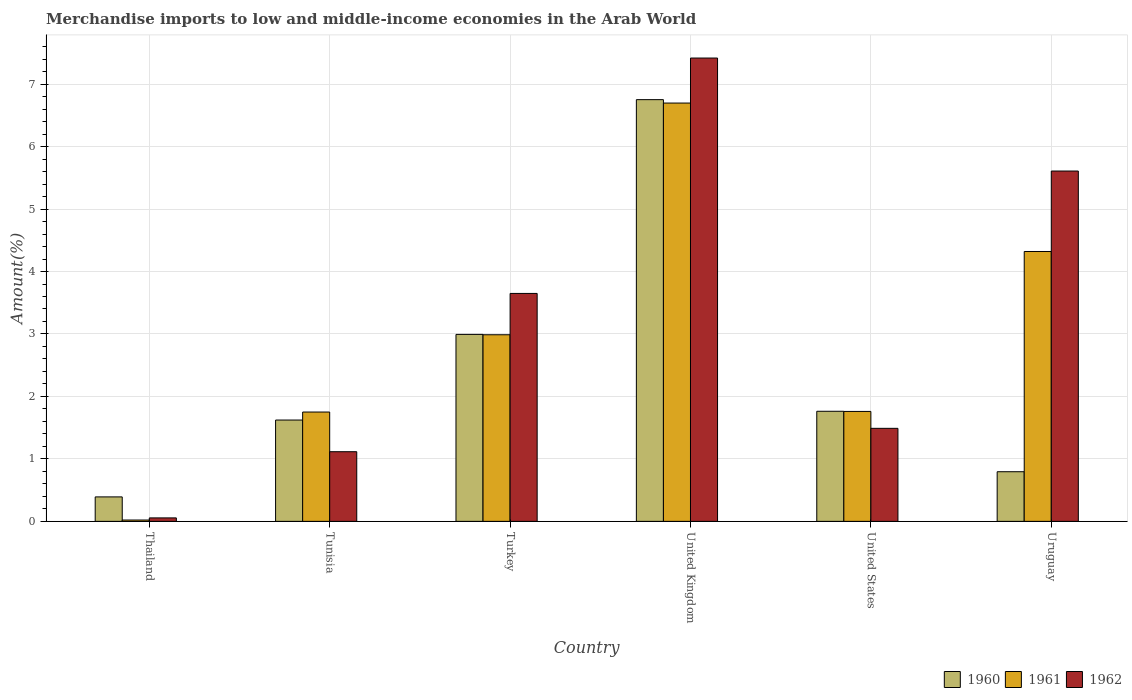How many groups of bars are there?
Ensure brevity in your answer.  6. Are the number of bars per tick equal to the number of legend labels?
Provide a succinct answer. Yes. How many bars are there on the 3rd tick from the left?
Ensure brevity in your answer.  3. How many bars are there on the 4th tick from the right?
Ensure brevity in your answer.  3. What is the label of the 4th group of bars from the left?
Offer a terse response. United Kingdom. What is the percentage of amount earned from merchandise imports in 1961 in Thailand?
Ensure brevity in your answer.  0.02. Across all countries, what is the maximum percentage of amount earned from merchandise imports in 1962?
Make the answer very short. 7.42. Across all countries, what is the minimum percentage of amount earned from merchandise imports in 1962?
Give a very brief answer. 0.06. In which country was the percentage of amount earned from merchandise imports in 1961 maximum?
Provide a short and direct response. United Kingdom. In which country was the percentage of amount earned from merchandise imports in 1961 minimum?
Your answer should be very brief. Thailand. What is the total percentage of amount earned from merchandise imports in 1961 in the graph?
Your answer should be compact. 17.54. What is the difference between the percentage of amount earned from merchandise imports in 1961 in United Kingdom and that in United States?
Your response must be concise. 4.94. What is the difference between the percentage of amount earned from merchandise imports in 1962 in Thailand and the percentage of amount earned from merchandise imports in 1961 in Tunisia?
Provide a succinct answer. -1.69. What is the average percentage of amount earned from merchandise imports in 1961 per country?
Keep it short and to the point. 2.92. What is the difference between the percentage of amount earned from merchandise imports of/in 1960 and percentage of amount earned from merchandise imports of/in 1961 in Thailand?
Keep it short and to the point. 0.37. In how many countries, is the percentage of amount earned from merchandise imports in 1960 greater than 3.6 %?
Your response must be concise. 1. What is the ratio of the percentage of amount earned from merchandise imports in 1961 in Tunisia to that in Uruguay?
Your answer should be very brief. 0.41. Is the percentage of amount earned from merchandise imports in 1962 in Tunisia less than that in United States?
Give a very brief answer. Yes. What is the difference between the highest and the second highest percentage of amount earned from merchandise imports in 1961?
Offer a terse response. -1.33. What is the difference between the highest and the lowest percentage of amount earned from merchandise imports in 1961?
Give a very brief answer. 6.68. How many bars are there?
Make the answer very short. 18. How many legend labels are there?
Make the answer very short. 3. What is the title of the graph?
Give a very brief answer. Merchandise imports to low and middle-income economies in the Arab World. Does "1966" appear as one of the legend labels in the graph?
Provide a short and direct response. No. What is the label or title of the X-axis?
Give a very brief answer. Country. What is the label or title of the Y-axis?
Make the answer very short. Amount(%). What is the Amount(%) of 1960 in Thailand?
Keep it short and to the point. 0.39. What is the Amount(%) in 1961 in Thailand?
Ensure brevity in your answer.  0.02. What is the Amount(%) of 1962 in Thailand?
Your answer should be very brief. 0.06. What is the Amount(%) of 1960 in Tunisia?
Make the answer very short. 1.62. What is the Amount(%) of 1961 in Tunisia?
Give a very brief answer. 1.75. What is the Amount(%) in 1962 in Tunisia?
Your answer should be very brief. 1.12. What is the Amount(%) of 1960 in Turkey?
Your answer should be compact. 2.99. What is the Amount(%) in 1961 in Turkey?
Offer a very short reply. 2.99. What is the Amount(%) of 1962 in Turkey?
Make the answer very short. 3.65. What is the Amount(%) of 1960 in United Kingdom?
Provide a succinct answer. 6.75. What is the Amount(%) of 1961 in United Kingdom?
Ensure brevity in your answer.  6.7. What is the Amount(%) in 1962 in United Kingdom?
Provide a succinct answer. 7.42. What is the Amount(%) of 1960 in United States?
Offer a very short reply. 1.76. What is the Amount(%) in 1961 in United States?
Your answer should be very brief. 1.76. What is the Amount(%) of 1962 in United States?
Ensure brevity in your answer.  1.49. What is the Amount(%) in 1960 in Uruguay?
Your answer should be compact. 0.79. What is the Amount(%) in 1961 in Uruguay?
Your response must be concise. 4.32. What is the Amount(%) of 1962 in Uruguay?
Your response must be concise. 5.61. Across all countries, what is the maximum Amount(%) in 1960?
Give a very brief answer. 6.75. Across all countries, what is the maximum Amount(%) in 1961?
Keep it short and to the point. 6.7. Across all countries, what is the maximum Amount(%) in 1962?
Offer a very short reply. 7.42. Across all countries, what is the minimum Amount(%) in 1960?
Keep it short and to the point. 0.39. Across all countries, what is the minimum Amount(%) in 1961?
Provide a short and direct response. 0.02. Across all countries, what is the minimum Amount(%) of 1962?
Your answer should be compact. 0.06. What is the total Amount(%) in 1960 in the graph?
Keep it short and to the point. 14.32. What is the total Amount(%) in 1961 in the graph?
Your answer should be very brief. 17.54. What is the total Amount(%) of 1962 in the graph?
Ensure brevity in your answer.  19.34. What is the difference between the Amount(%) of 1960 in Thailand and that in Tunisia?
Keep it short and to the point. -1.23. What is the difference between the Amount(%) in 1961 in Thailand and that in Tunisia?
Your answer should be very brief. -1.73. What is the difference between the Amount(%) of 1962 in Thailand and that in Tunisia?
Your answer should be compact. -1.06. What is the difference between the Amount(%) in 1960 in Thailand and that in Turkey?
Provide a succinct answer. -2.6. What is the difference between the Amount(%) of 1961 in Thailand and that in Turkey?
Provide a short and direct response. -2.97. What is the difference between the Amount(%) of 1962 in Thailand and that in Turkey?
Provide a succinct answer. -3.59. What is the difference between the Amount(%) of 1960 in Thailand and that in United Kingdom?
Provide a succinct answer. -6.36. What is the difference between the Amount(%) in 1961 in Thailand and that in United Kingdom?
Keep it short and to the point. -6.68. What is the difference between the Amount(%) of 1962 in Thailand and that in United Kingdom?
Make the answer very short. -7.36. What is the difference between the Amount(%) of 1960 in Thailand and that in United States?
Your answer should be compact. -1.37. What is the difference between the Amount(%) of 1961 in Thailand and that in United States?
Make the answer very short. -1.74. What is the difference between the Amount(%) in 1962 in Thailand and that in United States?
Ensure brevity in your answer.  -1.43. What is the difference between the Amount(%) of 1960 in Thailand and that in Uruguay?
Offer a very short reply. -0.4. What is the difference between the Amount(%) in 1961 in Thailand and that in Uruguay?
Give a very brief answer. -4.3. What is the difference between the Amount(%) of 1962 in Thailand and that in Uruguay?
Offer a terse response. -5.55. What is the difference between the Amount(%) of 1960 in Tunisia and that in Turkey?
Provide a succinct answer. -1.37. What is the difference between the Amount(%) of 1961 in Tunisia and that in Turkey?
Keep it short and to the point. -1.24. What is the difference between the Amount(%) in 1962 in Tunisia and that in Turkey?
Provide a short and direct response. -2.53. What is the difference between the Amount(%) in 1960 in Tunisia and that in United Kingdom?
Make the answer very short. -5.13. What is the difference between the Amount(%) in 1961 in Tunisia and that in United Kingdom?
Offer a terse response. -4.95. What is the difference between the Amount(%) of 1962 in Tunisia and that in United Kingdom?
Ensure brevity in your answer.  -6.3. What is the difference between the Amount(%) in 1960 in Tunisia and that in United States?
Offer a terse response. -0.14. What is the difference between the Amount(%) in 1961 in Tunisia and that in United States?
Offer a very short reply. -0.01. What is the difference between the Amount(%) of 1962 in Tunisia and that in United States?
Your response must be concise. -0.37. What is the difference between the Amount(%) of 1960 in Tunisia and that in Uruguay?
Give a very brief answer. 0.83. What is the difference between the Amount(%) of 1961 in Tunisia and that in Uruguay?
Give a very brief answer. -2.57. What is the difference between the Amount(%) of 1962 in Tunisia and that in Uruguay?
Your answer should be compact. -4.49. What is the difference between the Amount(%) in 1960 in Turkey and that in United Kingdom?
Give a very brief answer. -3.76. What is the difference between the Amount(%) in 1961 in Turkey and that in United Kingdom?
Your response must be concise. -3.71. What is the difference between the Amount(%) of 1962 in Turkey and that in United Kingdom?
Make the answer very short. -3.77. What is the difference between the Amount(%) in 1960 in Turkey and that in United States?
Offer a very short reply. 1.23. What is the difference between the Amount(%) of 1961 in Turkey and that in United States?
Your answer should be very brief. 1.23. What is the difference between the Amount(%) of 1962 in Turkey and that in United States?
Keep it short and to the point. 2.16. What is the difference between the Amount(%) in 1960 in Turkey and that in Uruguay?
Provide a short and direct response. 2.2. What is the difference between the Amount(%) in 1961 in Turkey and that in Uruguay?
Provide a short and direct response. -1.33. What is the difference between the Amount(%) in 1962 in Turkey and that in Uruguay?
Provide a short and direct response. -1.96. What is the difference between the Amount(%) in 1960 in United Kingdom and that in United States?
Your answer should be very brief. 4.99. What is the difference between the Amount(%) in 1961 in United Kingdom and that in United States?
Give a very brief answer. 4.94. What is the difference between the Amount(%) in 1962 in United Kingdom and that in United States?
Your answer should be compact. 5.93. What is the difference between the Amount(%) in 1960 in United Kingdom and that in Uruguay?
Your response must be concise. 5.96. What is the difference between the Amount(%) in 1961 in United Kingdom and that in Uruguay?
Your answer should be compact. 2.38. What is the difference between the Amount(%) of 1962 in United Kingdom and that in Uruguay?
Your answer should be compact. 1.81. What is the difference between the Amount(%) of 1960 in United States and that in Uruguay?
Your response must be concise. 0.97. What is the difference between the Amount(%) of 1961 in United States and that in Uruguay?
Provide a short and direct response. -2.56. What is the difference between the Amount(%) of 1962 in United States and that in Uruguay?
Offer a very short reply. -4.12. What is the difference between the Amount(%) in 1960 in Thailand and the Amount(%) in 1961 in Tunisia?
Keep it short and to the point. -1.36. What is the difference between the Amount(%) in 1960 in Thailand and the Amount(%) in 1962 in Tunisia?
Make the answer very short. -0.72. What is the difference between the Amount(%) in 1961 in Thailand and the Amount(%) in 1962 in Tunisia?
Offer a very short reply. -1.09. What is the difference between the Amount(%) of 1960 in Thailand and the Amount(%) of 1961 in Turkey?
Offer a terse response. -2.6. What is the difference between the Amount(%) of 1960 in Thailand and the Amount(%) of 1962 in Turkey?
Your answer should be compact. -3.26. What is the difference between the Amount(%) in 1961 in Thailand and the Amount(%) in 1962 in Turkey?
Ensure brevity in your answer.  -3.63. What is the difference between the Amount(%) of 1960 in Thailand and the Amount(%) of 1961 in United Kingdom?
Provide a succinct answer. -6.31. What is the difference between the Amount(%) in 1960 in Thailand and the Amount(%) in 1962 in United Kingdom?
Provide a short and direct response. -7.03. What is the difference between the Amount(%) in 1961 in Thailand and the Amount(%) in 1962 in United Kingdom?
Offer a very short reply. -7.4. What is the difference between the Amount(%) in 1960 in Thailand and the Amount(%) in 1961 in United States?
Offer a very short reply. -1.37. What is the difference between the Amount(%) in 1960 in Thailand and the Amount(%) in 1962 in United States?
Provide a short and direct response. -1.1. What is the difference between the Amount(%) of 1961 in Thailand and the Amount(%) of 1962 in United States?
Make the answer very short. -1.47. What is the difference between the Amount(%) of 1960 in Thailand and the Amount(%) of 1961 in Uruguay?
Provide a succinct answer. -3.93. What is the difference between the Amount(%) in 1960 in Thailand and the Amount(%) in 1962 in Uruguay?
Make the answer very short. -5.22. What is the difference between the Amount(%) in 1961 in Thailand and the Amount(%) in 1962 in Uruguay?
Ensure brevity in your answer.  -5.59. What is the difference between the Amount(%) of 1960 in Tunisia and the Amount(%) of 1961 in Turkey?
Keep it short and to the point. -1.37. What is the difference between the Amount(%) of 1960 in Tunisia and the Amount(%) of 1962 in Turkey?
Provide a short and direct response. -2.03. What is the difference between the Amount(%) in 1961 in Tunisia and the Amount(%) in 1962 in Turkey?
Offer a terse response. -1.9. What is the difference between the Amount(%) in 1960 in Tunisia and the Amount(%) in 1961 in United Kingdom?
Your response must be concise. -5.07. What is the difference between the Amount(%) of 1960 in Tunisia and the Amount(%) of 1962 in United Kingdom?
Your answer should be compact. -5.8. What is the difference between the Amount(%) of 1961 in Tunisia and the Amount(%) of 1962 in United Kingdom?
Your answer should be compact. -5.67. What is the difference between the Amount(%) of 1960 in Tunisia and the Amount(%) of 1961 in United States?
Ensure brevity in your answer.  -0.14. What is the difference between the Amount(%) of 1960 in Tunisia and the Amount(%) of 1962 in United States?
Offer a terse response. 0.13. What is the difference between the Amount(%) of 1961 in Tunisia and the Amount(%) of 1962 in United States?
Give a very brief answer. 0.26. What is the difference between the Amount(%) of 1960 in Tunisia and the Amount(%) of 1961 in Uruguay?
Your answer should be very brief. -2.7. What is the difference between the Amount(%) in 1960 in Tunisia and the Amount(%) in 1962 in Uruguay?
Your answer should be very brief. -3.99. What is the difference between the Amount(%) of 1961 in Tunisia and the Amount(%) of 1962 in Uruguay?
Provide a short and direct response. -3.86. What is the difference between the Amount(%) in 1960 in Turkey and the Amount(%) in 1961 in United Kingdom?
Give a very brief answer. -3.7. What is the difference between the Amount(%) in 1960 in Turkey and the Amount(%) in 1962 in United Kingdom?
Your answer should be very brief. -4.42. What is the difference between the Amount(%) in 1961 in Turkey and the Amount(%) in 1962 in United Kingdom?
Your answer should be compact. -4.43. What is the difference between the Amount(%) in 1960 in Turkey and the Amount(%) in 1961 in United States?
Your response must be concise. 1.23. What is the difference between the Amount(%) of 1960 in Turkey and the Amount(%) of 1962 in United States?
Provide a succinct answer. 1.5. What is the difference between the Amount(%) of 1961 in Turkey and the Amount(%) of 1962 in United States?
Give a very brief answer. 1.5. What is the difference between the Amount(%) of 1960 in Turkey and the Amount(%) of 1961 in Uruguay?
Offer a very short reply. -1.33. What is the difference between the Amount(%) of 1960 in Turkey and the Amount(%) of 1962 in Uruguay?
Ensure brevity in your answer.  -2.62. What is the difference between the Amount(%) of 1961 in Turkey and the Amount(%) of 1962 in Uruguay?
Offer a terse response. -2.62. What is the difference between the Amount(%) in 1960 in United Kingdom and the Amount(%) in 1961 in United States?
Provide a short and direct response. 4.99. What is the difference between the Amount(%) in 1960 in United Kingdom and the Amount(%) in 1962 in United States?
Provide a short and direct response. 5.26. What is the difference between the Amount(%) of 1961 in United Kingdom and the Amount(%) of 1962 in United States?
Provide a succinct answer. 5.21. What is the difference between the Amount(%) in 1960 in United Kingdom and the Amount(%) in 1961 in Uruguay?
Ensure brevity in your answer.  2.43. What is the difference between the Amount(%) in 1960 in United Kingdom and the Amount(%) in 1962 in Uruguay?
Your response must be concise. 1.14. What is the difference between the Amount(%) in 1961 in United Kingdom and the Amount(%) in 1962 in Uruguay?
Your answer should be very brief. 1.09. What is the difference between the Amount(%) of 1960 in United States and the Amount(%) of 1961 in Uruguay?
Make the answer very short. -2.56. What is the difference between the Amount(%) of 1960 in United States and the Amount(%) of 1962 in Uruguay?
Your answer should be very brief. -3.85. What is the difference between the Amount(%) in 1961 in United States and the Amount(%) in 1962 in Uruguay?
Offer a terse response. -3.85. What is the average Amount(%) in 1960 per country?
Offer a very short reply. 2.39. What is the average Amount(%) in 1961 per country?
Your response must be concise. 2.92. What is the average Amount(%) in 1962 per country?
Offer a very short reply. 3.22. What is the difference between the Amount(%) of 1960 and Amount(%) of 1961 in Thailand?
Your response must be concise. 0.37. What is the difference between the Amount(%) in 1960 and Amount(%) in 1962 in Thailand?
Your answer should be compact. 0.34. What is the difference between the Amount(%) of 1961 and Amount(%) of 1962 in Thailand?
Provide a short and direct response. -0.03. What is the difference between the Amount(%) of 1960 and Amount(%) of 1961 in Tunisia?
Your answer should be very brief. -0.13. What is the difference between the Amount(%) in 1960 and Amount(%) in 1962 in Tunisia?
Give a very brief answer. 0.51. What is the difference between the Amount(%) of 1961 and Amount(%) of 1962 in Tunisia?
Offer a very short reply. 0.64. What is the difference between the Amount(%) of 1960 and Amount(%) of 1961 in Turkey?
Your response must be concise. 0.01. What is the difference between the Amount(%) of 1960 and Amount(%) of 1962 in Turkey?
Offer a very short reply. -0.66. What is the difference between the Amount(%) of 1961 and Amount(%) of 1962 in Turkey?
Provide a short and direct response. -0.66. What is the difference between the Amount(%) in 1960 and Amount(%) in 1961 in United Kingdom?
Your response must be concise. 0.05. What is the difference between the Amount(%) in 1960 and Amount(%) in 1962 in United Kingdom?
Offer a terse response. -0.67. What is the difference between the Amount(%) of 1961 and Amount(%) of 1962 in United Kingdom?
Keep it short and to the point. -0.72. What is the difference between the Amount(%) in 1960 and Amount(%) in 1961 in United States?
Provide a short and direct response. 0. What is the difference between the Amount(%) of 1960 and Amount(%) of 1962 in United States?
Provide a succinct answer. 0.27. What is the difference between the Amount(%) of 1961 and Amount(%) of 1962 in United States?
Ensure brevity in your answer.  0.27. What is the difference between the Amount(%) in 1960 and Amount(%) in 1961 in Uruguay?
Your answer should be compact. -3.53. What is the difference between the Amount(%) in 1960 and Amount(%) in 1962 in Uruguay?
Offer a very short reply. -4.81. What is the difference between the Amount(%) of 1961 and Amount(%) of 1962 in Uruguay?
Give a very brief answer. -1.29. What is the ratio of the Amount(%) in 1960 in Thailand to that in Tunisia?
Offer a terse response. 0.24. What is the ratio of the Amount(%) in 1961 in Thailand to that in Tunisia?
Your answer should be very brief. 0.01. What is the ratio of the Amount(%) in 1962 in Thailand to that in Tunisia?
Keep it short and to the point. 0.05. What is the ratio of the Amount(%) in 1960 in Thailand to that in Turkey?
Keep it short and to the point. 0.13. What is the ratio of the Amount(%) in 1961 in Thailand to that in Turkey?
Provide a succinct answer. 0.01. What is the ratio of the Amount(%) in 1962 in Thailand to that in Turkey?
Offer a terse response. 0.02. What is the ratio of the Amount(%) in 1960 in Thailand to that in United Kingdom?
Your answer should be compact. 0.06. What is the ratio of the Amount(%) in 1961 in Thailand to that in United Kingdom?
Your answer should be compact. 0. What is the ratio of the Amount(%) in 1962 in Thailand to that in United Kingdom?
Your answer should be very brief. 0.01. What is the ratio of the Amount(%) of 1960 in Thailand to that in United States?
Give a very brief answer. 0.22. What is the ratio of the Amount(%) in 1961 in Thailand to that in United States?
Offer a very short reply. 0.01. What is the ratio of the Amount(%) of 1962 in Thailand to that in United States?
Offer a terse response. 0.04. What is the ratio of the Amount(%) of 1960 in Thailand to that in Uruguay?
Ensure brevity in your answer.  0.49. What is the ratio of the Amount(%) in 1961 in Thailand to that in Uruguay?
Your answer should be very brief. 0. What is the ratio of the Amount(%) in 1962 in Thailand to that in Uruguay?
Your response must be concise. 0.01. What is the ratio of the Amount(%) of 1960 in Tunisia to that in Turkey?
Provide a succinct answer. 0.54. What is the ratio of the Amount(%) in 1961 in Tunisia to that in Turkey?
Your response must be concise. 0.59. What is the ratio of the Amount(%) in 1962 in Tunisia to that in Turkey?
Provide a short and direct response. 0.31. What is the ratio of the Amount(%) of 1960 in Tunisia to that in United Kingdom?
Provide a succinct answer. 0.24. What is the ratio of the Amount(%) of 1961 in Tunisia to that in United Kingdom?
Ensure brevity in your answer.  0.26. What is the ratio of the Amount(%) in 1962 in Tunisia to that in United Kingdom?
Keep it short and to the point. 0.15. What is the ratio of the Amount(%) in 1960 in Tunisia to that in United States?
Provide a short and direct response. 0.92. What is the ratio of the Amount(%) in 1961 in Tunisia to that in United States?
Keep it short and to the point. 0.99. What is the ratio of the Amount(%) of 1962 in Tunisia to that in United States?
Provide a short and direct response. 0.75. What is the ratio of the Amount(%) in 1960 in Tunisia to that in Uruguay?
Make the answer very short. 2.04. What is the ratio of the Amount(%) in 1961 in Tunisia to that in Uruguay?
Offer a terse response. 0.41. What is the ratio of the Amount(%) in 1962 in Tunisia to that in Uruguay?
Provide a short and direct response. 0.2. What is the ratio of the Amount(%) of 1960 in Turkey to that in United Kingdom?
Provide a succinct answer. 0.44. What is the ratio of the Amount(%) of 1961 in Turkey to that in United Kingdom?
Offer a terse response. 0.45. What is the ratio of the Amount(%) in 1962 in Turkey to that in United Kingdom?
Ensure brevity in your answer.  0.49. What is the ratio of the Amount(%) of 1960 in Turkey to that in United States?
Offer a terse response. 1.7. What is the ratio of the Amount(%) of 1961 in Turkey to that in United States?
Your answer should be compact. 1.7. What is the ratio of the Amount(%) of 1962 in Turkey to that in United States?
Offer a terse response. 2.45. What is the ratio of the Amount(%) of 1960 in Turkey to that in Uruguay?
Your response must be concise. 3.77. What is the ratio of the Amount(%) of 1961 in Turkey to that in Uruguay?
Provide a short and direct response. 0.69. What is the ratio of the Amount(%) of 1962 in Turkey to that in Uruguay?
Your answer should be compact. 0.65. What is the ratio of the Amount(%) in 1960 in United Kingdom to that in United States?
Make the answer very short. 3.83. What is the ratio of the Amount(%) in 1961 in United Kingdom to that in United States?
Your answer should be very brief. 3.81. What is the ratio of the Amount(%) of 1962 in United Kingdom to that in United States?
Offer a very short reply. 4.98. What is the ratio of the Amount(%) in 1960 in United Kingdom to that in Uruguay?
Your answer should be compact. 8.5. What is the ratio of the Amount(%) of 1961 in United Kingdom to that in Uruguay?
Your answer should be very brief. 1.55. What is the ratio of the Amount(%) in 1962 in United Kingdom to that in Uruguay?
Make the answer very short. 1.32. What is the ratio of the Amount(%) in 1960 in United States to that in Uruguay?
Your answer should be compact. 2.22. What is the ratio of the Amount(%) in 1961 in United States to that in Uruguay?
Your response must be concise. 0.41. What is the ratio of the Amount(%) in 1962 in United States to that in Uruguay?
Your answer should be very brief. 0.27. What is the difference between the highest and the second highest Amount(%) in 1960?
Your answer should be compact. 3.76. What is the difference between the highest and the second highest Amount(%) in 1961?
Keep it short and to the point. 2.38. What is the difference between the highest and the second highest Amount(%) in 1962?
Ensure brevity in your answer.  1.81. What is the difference between the highest and the lowest Amount(%) in 1960?
Ensure brevity in your answer.  6.36. What is the difference between the highest and the lowest Amount(%) of 1961?
Give a very brief answer. 6.68. What is the difference between the highest and the lowest Amount(%) of 1962?
Provide a succinct answer. 7.36. 